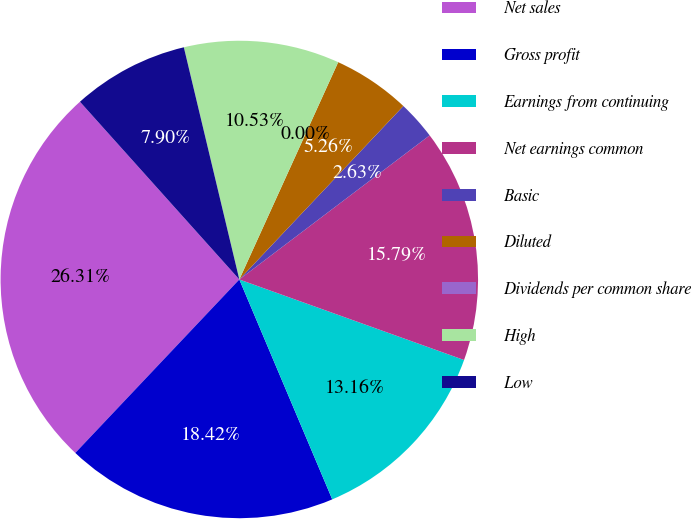Convert chart. <chart><loc_0><loc_0><loc_500><loc_500><pie_chart><fcel>Net sales<fcel>Gross profit<fcel>Earnings from continuing<fcel>Net earnings common<fcel>Basic<fcel>Diluted<fcel>Dividends per common share<fcel>High<fcel>Low<nl><fcel>26.31%<fcel>18.42%<fcel>13.16%<fcel>15.79%<fcel>2.63%<fcel>5.26%<fcel>0.0%<fcel>10.53%<fcel>7.9%<nl></chart> 